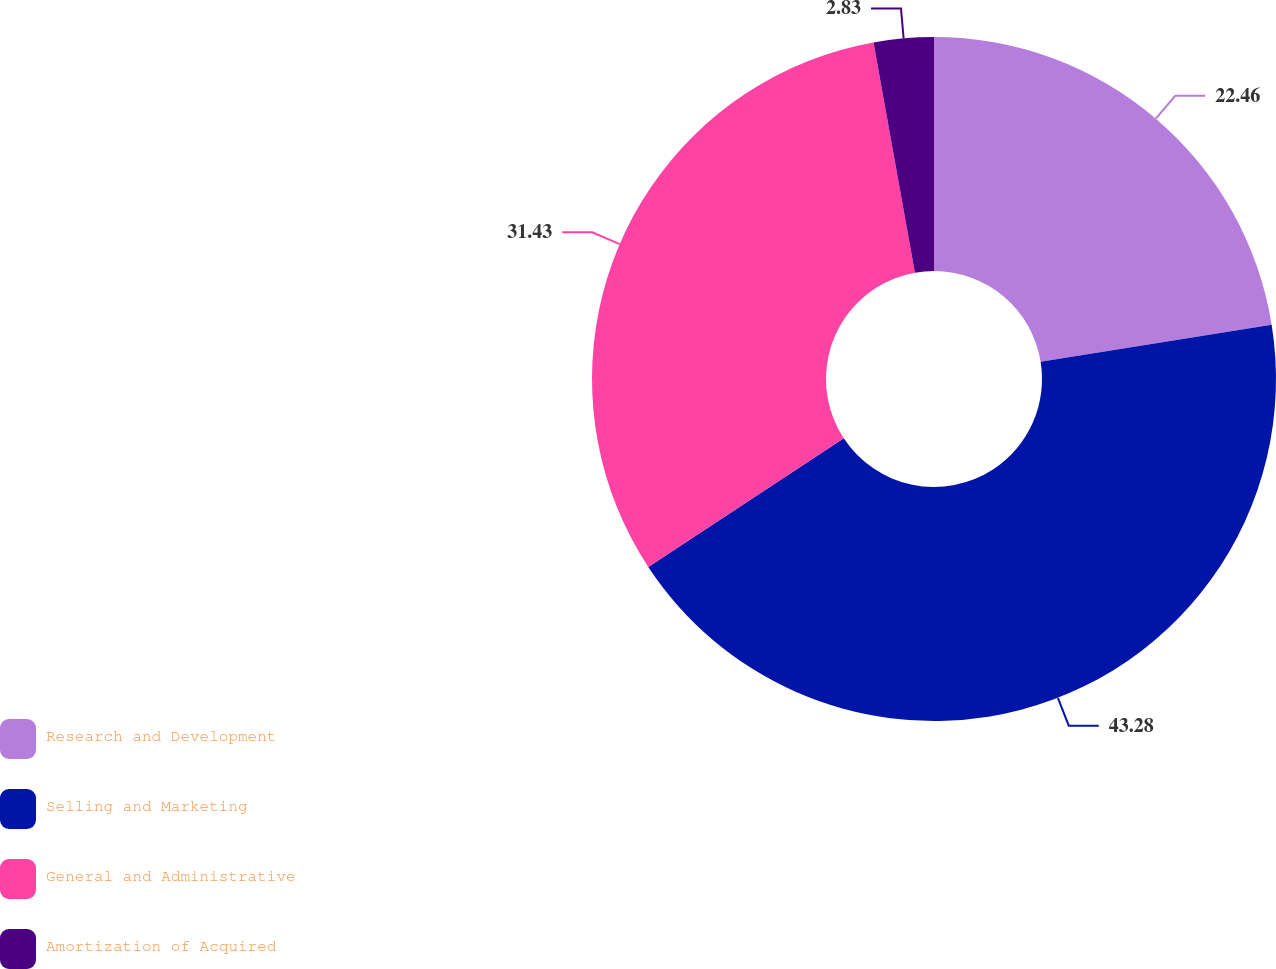Convert chart to OTSL. <chart><loc_0><loc_0><loc_500><loc_500><pie_chart><fcel>Research and Development<fcel>Selling and Marketing<fcel>General and Administrative<fcel>Amortization of Acquired<nl><fcel>22.46%<fcel>43.28%<fcel>31.43%<fcel>2.83%<nl></chart> 